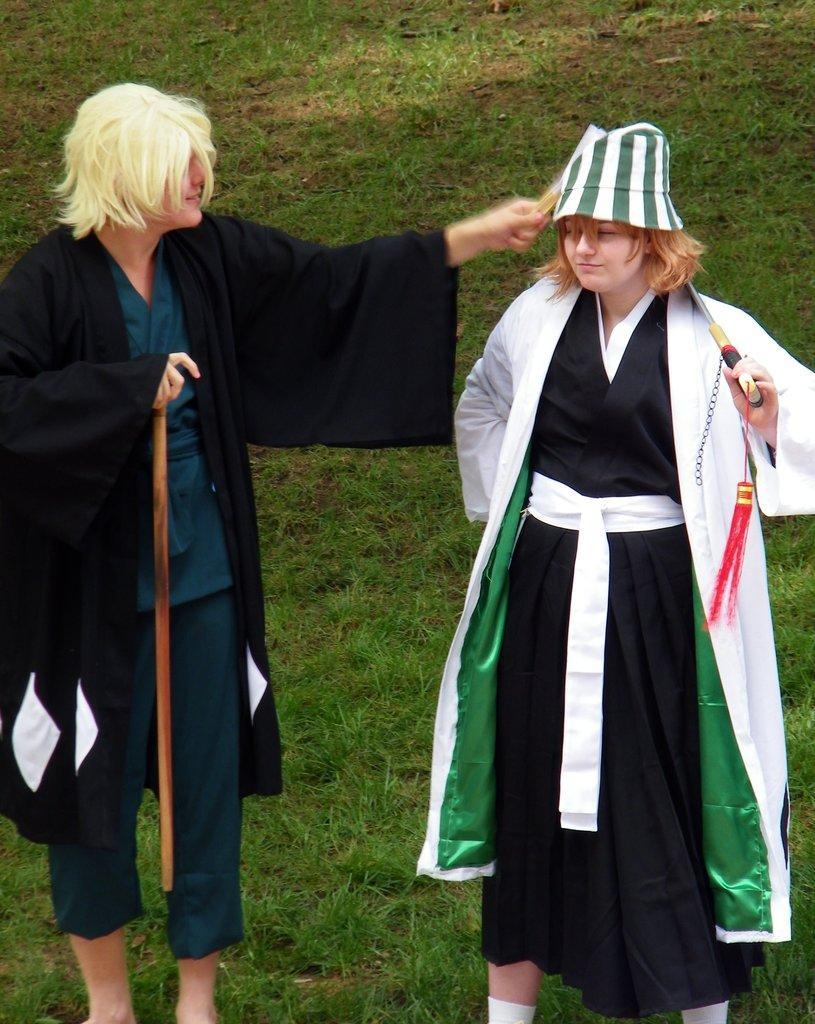In one or two sentences, can you explain what this image depicts? In this picture we can see a person holding a stick and standing on the grass. We can see a woman holding an object in her hand and standing on the grass. Grass is visible throughout the image. 